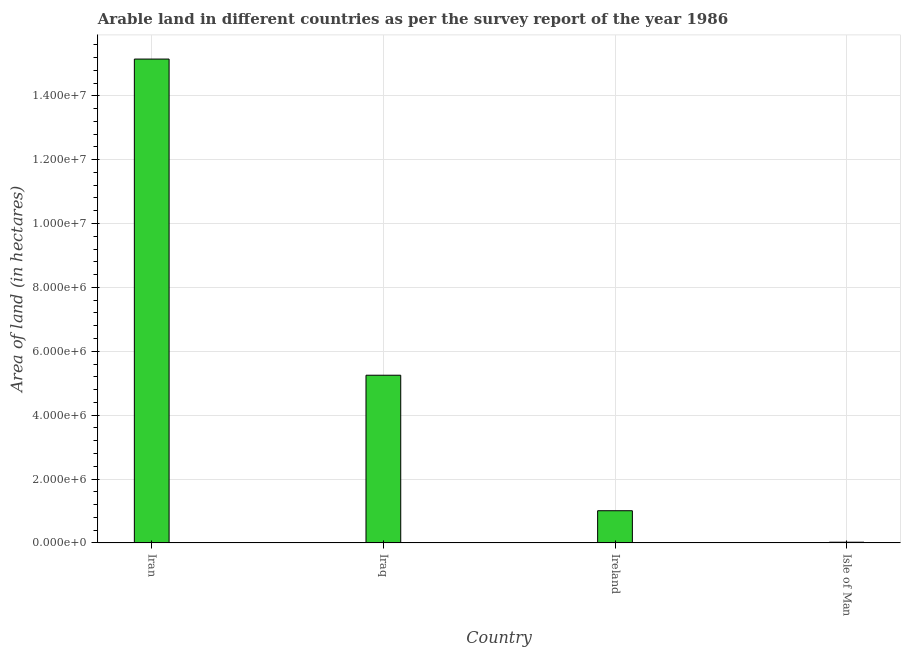Does the graph contain any zero values?
Provide a short and direct response. No. Does the graph contain grids?
Your answer should be compact. Yes. What is the title of the graph?
Give a very brief answer. Arable land in different countries as per the survey report of the year 1986. What is the label or title of the Y-axis?
Ensure brevity in your answer.  Area of land (in hectares). What is the area of land in Ireland?
Offer a terse response. 1.01e+06. Across all countries, what is the maximum area of land?
Make the answer very short. 1.52e+07. Across all countries, what is the minimum area of land?
Give a very brief answer. 2.09e+04. In which country was the area of land maximum?
Give a very brief answer. Iran. In which country was the area of land minimum?
Make the answer very short. Isle of Man. What is the sum of the area of land?
Give a very brief answer. 2.14e+07. What is the difference between the area of land in Ireland and Isle of Man?
Offer a very short reply. 9.86e+05. What is the average area of land per country?
Give a very brief answer. 5.36e+06. What is the median area of land?
Provide a succinct answer. 3.13e+06. In how many countries, is the area of land greater than 9600000 hectares?
Make the answer very short. 1. What is the ratio of the area of land in Ireland to that in Isle of Man?
Make the answer very short. 48.18. Is the area of land in Iran less than that in Iraq?
Offer a terse response. No. Is the difference between the area of land in Iran and Isle of Man greater than the difference between any two countries?
Ensure brevity in your answer.  Yes. What is the difference between the highest and the second highest area of land?
Provide a short and direct response. 9.90e+06. What is the difference between the highest and the lowest area of land?
Make the answer very short. 1.51e+07. How many bars are there?
Your answer should be compact. 4. Are all the bars in the graph horizontal?
Your answer should be very brief. No. How many countries are there in the graph?
Keep it short and to the point. 4. What is the difference between two consecutive major ticks on the Y-axis?
Your response must be concise. 2.00e+06. Are the values on the major ticks of Y-axis written in scientific E-notation?
Ensure brevity in your answer.  Yes. What is the Area of land (in hectares) of Iran?
Keep it short and to the point. 1.52e+07. What is the Area of land (in hectares) of Iraq?
Give a very brief answer. 5.25e+06. What is the Area of land (in hectares) of Ireland?
Give a very brief answer. 1.01e+06. What is the Area of land (in hectares) in Isle of Man?
Your answer should be very brief. 2.09e+04. What is the difference between the Area of land (in hectares) in Iran and Iraq?
Keep it short and to the point. 9.90e+06. What is the difference between the Area of land (in hectares) in Iran and Ireland?
Your answer should be very brief. 1.41e+07. What is the difference between the Area of land (in hectares) in Iran and Isle of Man?
Provide a succinct answer. 1.51e+07. What is the difference between the Area of land (in hectares) in Iraq and Ireland?
Make the answer very short. 4.24e+06. What is the difference between the Area of land (in hectares) in Iraq and Isle of Man?
Give a very brief answer. 5.23e+06. What is the difference between the Area of land (in hectares) in Ireland and Isle of Man?
Provide a short and direct response. 9.86e+05. What is the ratio of the Area of land (in hectares) in Iran to that in Iraq?
Provide a succinct answer. 2.89. What is the ratio of the Area of land (in hectares) in Iran to that in Ireland?
Your answer should be compact. 15.04. What is the ratio of the Area of land (in hectares) in Iran to that in Isle of Man?
Your answer should be very brief. 724.88. What is the ratio of the Area of land (in hectares) in Iraq to that in Ireland?
Offer a terse response. 5.21. What is the ratio of the Area of land (in hectares) in Iraq to that in Isle of Man?
Your response must be concise. 251.2. What is the ratio of the Area of land (in hectares) in Ireland to that in Isle of Man?
Offer a terse response. 48.18. 